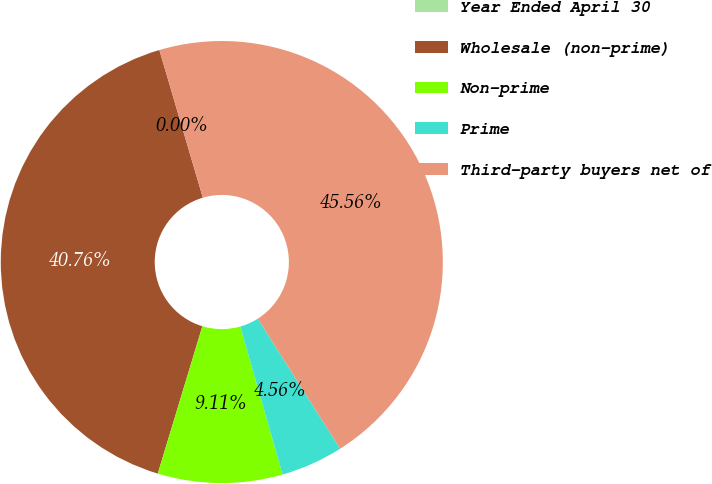Convert chart to OTSL. <chart><loc_0><loc_0><loc_500><loc_500><pie_chart><fcel>Year Ended April 30<fcel>Wholesale (non-prime)<fcel>Non-prime<fcel>Prime<fcel>Third-party buyers net of<nl><fcel>0.0%<fcel>40.76%<fcel>9.11%<fcel>4.56%<fcel>45.56%<nl></chart> 